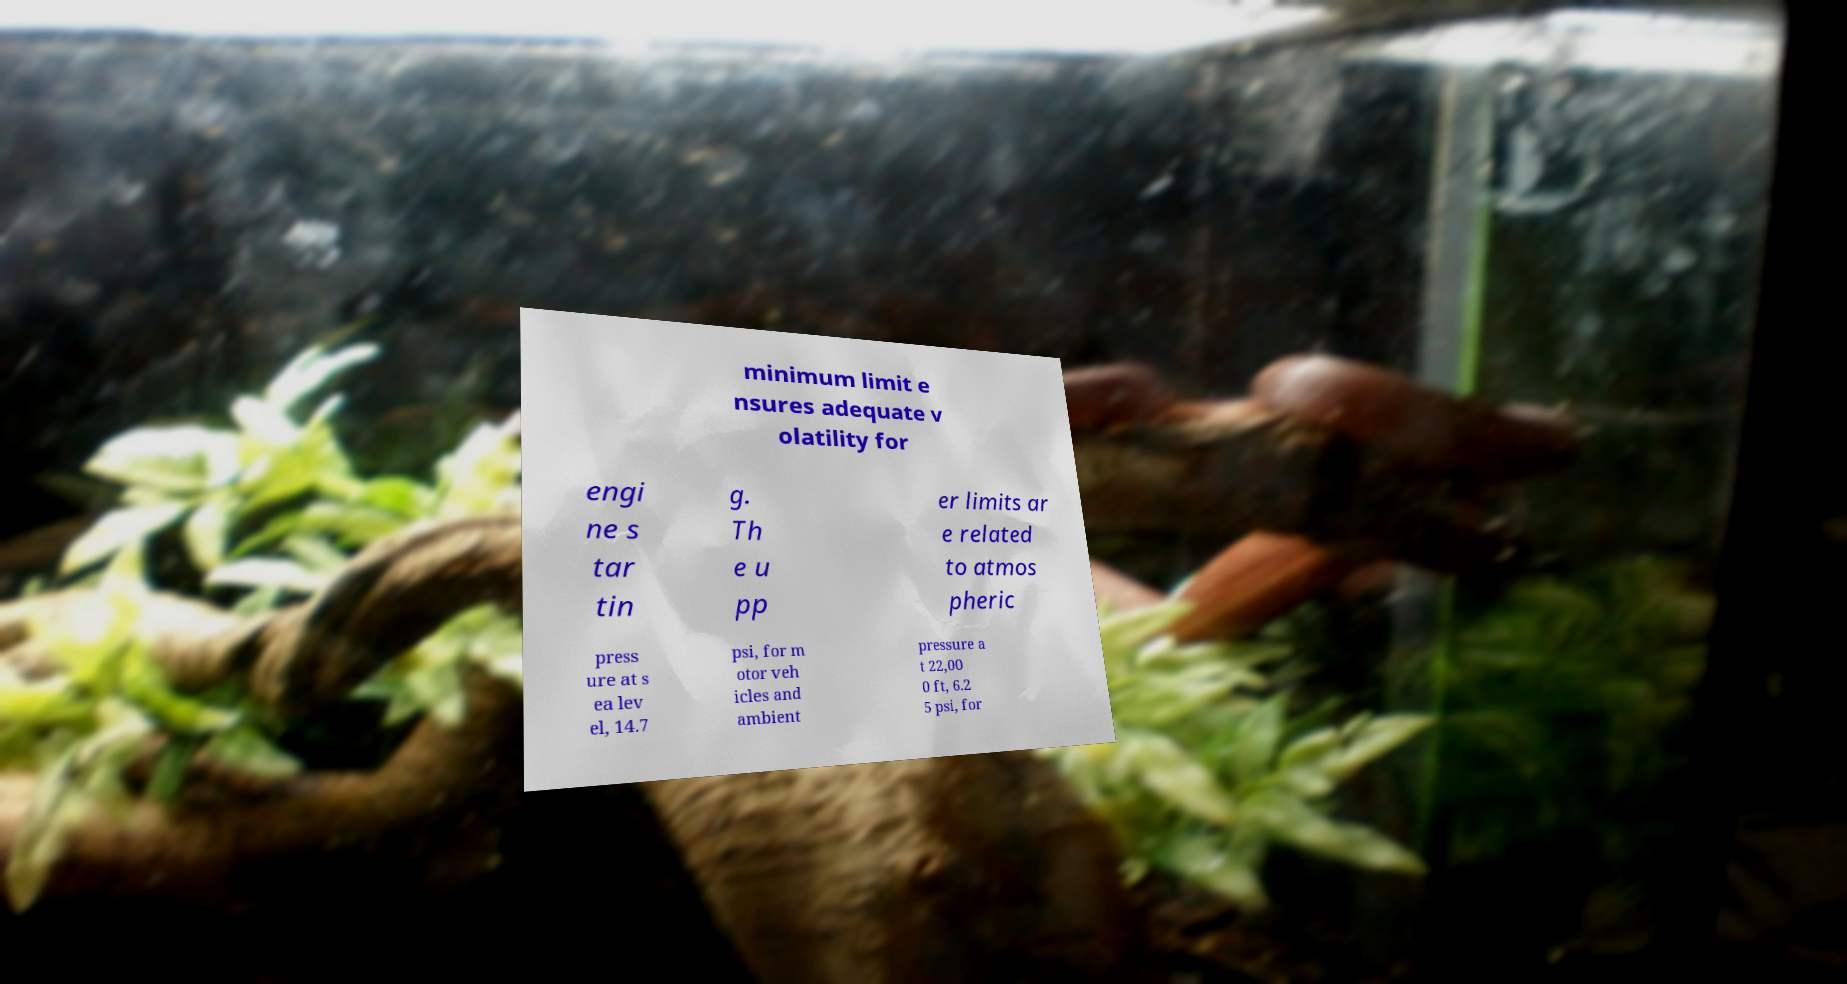Please identify and transcribe the text found in this image. minimum limit e nsures adequate v olatility for engi ne s tar tin g. Th e u pp er limits ar e related to atmos pheric press ure at s ea lev el, 14.7 psi, for m otor veh icles and ambient pressure a t 22,00 0 ft, 6.2 5 psi, for 